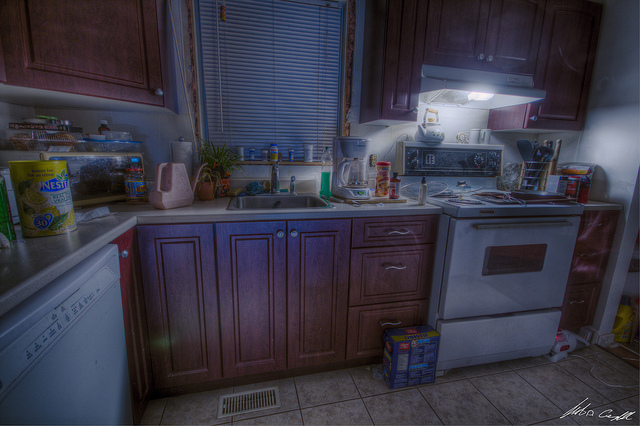<image>What pattern is the pot in the upper right corner? It is not possible to determine the pattern on the pot in the upper right corner. However, it could be flowers, solid, plaid, checkerboard, stripes or plain. What pattern is the pot in the upper right corner? It is ambiguous what pattern the pot in the upper right corner is. It can be seen 'flowers', 'solid', 'plaid', 'checkerboard', 'stripes' or 'plain'. 